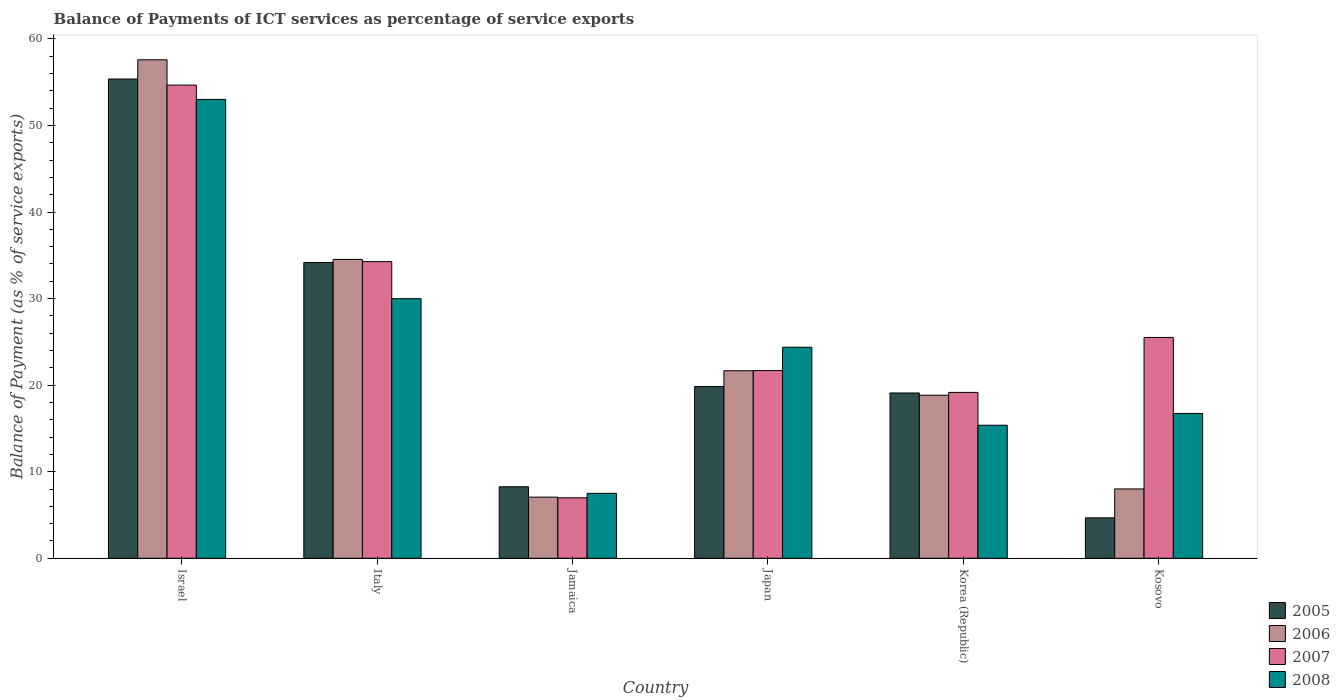How many different coloured bars are there?
Keep it short and to the point. 4. How many groups of bars are there?
Your answer should be compact. 6. What is the label of the 1st group of bars from the left?
Offer a terse response. Israel. In how many cases, is the number of bars for a given country not equal to the number of legend labels?
Ensure brevity in your answer.  0. What is the balance of payments of ICT services in 2006 in Jamaica?
Your answer should be compact. 7.06. Across all countries, what is the maximum balance of payments of ICT services in 2005?
Your response must be concise. 55.37. Across all countries, what is the minimum balance of payments of ICT services in 2006?
Your response must be concise. 7.06. In which country was the balance of payments of ICT services in 2008 maximum?
Give a very brief answer. Israel. In which country was the balance of payments of ICT services in 2005 minimum?
Provide a short and direct response. Kosovo. What is the total balance of payments of ICT services in 2006 in the graph?
Your response must be concise. 147.7. What is the difference between the balance of payments of ICT services in 2006 in Israel and that in Korea (Republic)?
Provide a short and direct response. 38.75. What is the difference between the balance of payments of ICT services in 2005 in Japan and the balance of payments of ICT services in 2006 in Italy?
Your response must be concise. -14.68. What is the average balance of payments of ICT services in 2008 per country?
Offer a terse response. 24.5. What is the difference between the balance of payments of ICT services of/in 2007 and balance of payments of ICT services of/in 2005 in Kosovo?
Keep it short and to the point. 20.84. What is the ratio of the balance of payments of ICT services in 2008 in Jamaica to that in Korea (Republic)?
Provide a succinct answer. 0.49. What is the difference between the highest and the second highest balance of payments of ICT services in 2008?
Give a very brief answer. -5.61. What is the difference between the highest and the lowest balance of payments of ICT services in 2006?
Give a very brief answer. 50.53. Is the sum of the balance of payments of ICT services in 2006 in Japan and Korea (Republic) greater than the maximum balance of payments of ICT services in 2007 across all countries?
Give a very brief answer. No. What does the 2nd bar from the left in Kosovo represents?
Offer a terse response. 2006. Is it the case that in every country, the sum of the balance of payments of ICT services in 2007 and balance of payments of ICT services in 2006 is greater than the balance of payments of ICT services in 2005?
Keep it short and to the point. Yes. Are all the bars in the graph horizontal?
Provide a succinct answer. No. Are the values on the major ticks of Y-axis written in scientific E-notation?
Ensure brevity in your answer.  No. Does the graph contain grids?
Keep it short and to the point. No. Where does the legend appear in the graph?
Your answer should be very brief. Bottom right. How many legend labels are there?
Offer a terse response. 4. What is the title of the graph?
Your answer should be compact. Balance of Payments of ICT services as percentage of service exports. Does "1991" appear as one of the legend labels in the graph?
Give a very brief answer. No. What is the label or title of the Y-axis?
Your answer should be compact. Balance of Payment (as % of service exports). What is the Balance of Payment (as % of service exports) in 2005 in Israel?
Provide a succinct answer. 55.37. What is the Balance of Payment (as % of service exports) in 2006 in Israel?
Offer a terse response. 57.59. What is the Balance of Payment (as % of service exports) in 2007 in Israel?
Your response must be concise. 54.67. What is the Balance of Payment (as % of service exports) in 2008 in Israel?
Offer a terse response. 53.02. What is the Balance of Payment (as % of service exports) in 2005 in Italy?
Your answer should be very brief. 34.17. What is the Balance of Payment (as % of service exports) of 2006 in Italy?
Offer a very short reply. 34.53. What is the Balance of Payment (as % of service exports) in 2007 in Italy?
Ensure brevity in your answer.  34.28. What is the Balance of Payment (as % of service exports) of 2008 in Italy?
Provide a short and direct response. 29.99. What is the Balance of Payment (as % of service exports) of 2005 in Jamaica?
Offer a very short reply. 8.26. What is the Balance of Payment (as % of service exports) in 2006 in Jamaica?
Your answer should be compact. 7.06. What is the Balance of Payment (as % of service exports) in 2007 in Jamaica?
Provide a succinct answer. 6.99. What is the Balance of Payment (as % of service exports) in 2008 in Jamaica?
Provide a short and direct response. 7.5. What is the Balance of Payment (as % of service exports) in 2005 in Japan?
Offer a very short reply. 19.85. What is the Balance of Payment (as % of service exports) of 2006 in Japan?
Your answer should be compact. 21.67. What is the Balance of Payment (as % of service exports) of 2007 in Japan?
Provide a short and direct response. 21.69. What is the Balance of Payment (as % of service exports) in 2008 in Japan?
Keep it short and to the point. 24.38. What is the Balance of Payment (as % of service exports) of 2005 in Korea (Republic)?
Make the answer very short. 19.1. What is the Balance of Payment (as % of service exports) of 2006 in Korea (Republic)?
Your answer should be compact. 18.84. What is the Balance of Payment (as % of service exports) in 2007 in Korea (Republic)?
Give a very brief answer. 19.16. What is the Balance of Payment (as % of service exports) in 2008 in Korea (Republic)?
Make the answer very short. 15.37. What is the Balance of Payment (as % of service exports) of 2005 in Kosovo?
Ensure brevity in your answer.  4.67. What is the Balance of Payment (as % of service exports) of 2006 in Kosovo?
Ensure brevity in your answer.  8.01. What is the Balance of Payment (as % of service exports) of 2007 in Kosovo?
Your response must be concise. 25.51. What is the Balance of Payment (as % of service exports) of 2008 in Kosovo?
Keep it short and to the point. 16.73. Across all countries, what is the maximum Balance of Payment (as % of service exports) of 2005?
Make the answer very short. 55.37. Across all countries, what is the maximum Balance of Payment (as % of service exports) of 2006?
Your response must be concise. 57.59. Across all countries, what is the maximum Balance of Payment (as % of service exports) in 2007?
Make the answer very short. 54.67. Across all countries, what is the maximum Balance of Payment (as % of service exports) of 2008?
Offer a very short reply. 53.02. Across all countries, what is the minimum Balance of Payment (as % of service exports) in 2005?
Provide a short and direct response. 4.67. Across all countries, what is the minimum Balance of Payment (as % of service exports) in 2006?
Your answer should be compact. 7.06. Across all countries, what is the minimum Balance of Payment (as % of service exports) of 2007?
Ensure brevity in your answer.  6.99. Across all countries, what is the minimum Balance of Payment (as % of service exports) in 2008?
Your response must be concise. 7.5. What is the total Balance of Payment (as % of service exports) in 2005 in the graph?
Keep it short and to the point. 141.43. What is the total Balance of Payment (as % of service exports) of 2006 in the graph?
Make the answer very short. 147.7. What is the total Balance of Payment (as % of service exports) of 2007 in the graph?
Provide a short and direct response. 162.29. What is the total Balance of Payment (as % of service exports) in 2008 in the graph?
Your answer should be compact. 147. What is the difference between the Balance of Payment (as % of service exports) of 2005 in Israel and that in Italy?
Provide a succinct answer. 21.2. What is the difference between the Balance of Payment (as % of service exports) of 2006 in Israel and that in Italy?
Make the answer very short. 23.06. What is the difference between the Balance of Payment (as % of service exports) of 2007 in Israel and that in Italy?
Your response must be concise. 20.39. What is the difference between the Balance of Payment (as % of service exports) in 2008 in Israel and that in Italy?
Your answer should be compact. 23.02. What is the difference between the Balance of Payment (as % of service exports) in 2005 in Israel and that in Jamaica?
Ensure brevity in your answer.  47.11. What is the difference between the Balance of Payment (as % of service exports) of 2006 in Israel and that in Jamaica?
Your response must be concise. 50.53. What is the difference between the Balance of Payment (as % of service exports) of 2007 in Israel and that in Jamaica?
Make the answer very short. 47.68. What is the difference between the Balance of Payment (as % of service exports) of 2008 in Israel and that in Jamaica?
Your answer should be very brief. 45.51. What is the difference between the Balance of Payment (as % of service exports) in 2005 in Israel and that in Japan?
Offer a terse response. 35.52. What is the difference between the Balance of Payment (as % of service exports) of 2006 in Israel and that in Japan?
Offer a very short reply. 35.93. What is the difference between the Balance of Payment (as % of service exports) of 2007 in Israel and that in Japan?
Offer a very short reply. 32.98. What is the difference between the Balance of Payment (as % of service exports) of 2008 in Israel and that in Japan?
Ensure brevity in your answer.  28.64. What is the difference between the Balance of Payment (as % of service exports) of 2005 in Israel and that in Korea (Republic)?
Provide a succinct answer. 36.28. What is the difference between the Balance of Payment (as % of service exports) of 2006 in Israel and that in Korea (Republic)?
Give a very brief answer. 38.75. What is the difference between the Balance of Payment (as % of service exports) of 2007 in Israel and that in Korea (Republic)?
Give a very brief answer. 35.5. What is the difference between the Balance of Payment (as % of service exports) of 2008 in Israel and that in Korea (Republic)?
Your answer should be compact. 37.64. What is the difference between the Balance of Payment (as % of service exports) in 2005 in Israel and that in Kosovo?
Your response must be concise. 50.7. What is the difference between the Balance of Payment (as % of service exports) of 2006 in Israel and that in Kosovo?
Ensure brevity in your answer.  49.58. What is the difference between the Balance of Payment (as % of service exports) of 2007 in Israel and that in Kosovo?
Provide a succinct answer. 29.15. What is the difference between the Balance of Payment (as % of service exports) of 2008 in Israel and that in Kosovo?
Your answer should be very brief. 36.29. What is the difference between the Balance of Payment (as % of service exports) of 2005 in Italy and that in Jamaica?
Ensure brevity in your answer.  25.91. What is the difference between the Balance of Payment (as % of service exports) in 2006 in Italy and that in Jamaica?
Your answer should be very brief. 27.47. What is the difference between the Balance of Payment (as % of service exports) in 2007 in Italy and that in Jamaica?
Give a very brief answer. 27.29. What is the difference between the Balance of Payment (as % of service exports) in 2008 in Italy and that in Jamaica?
Provide a short and direct response. 22.49. What is the difference between the Balance of Payment (as % of service exports) of 2005 in Italy and that in Japan?
Ensure brevity in your answer.  14.33. What is the difference between the Balance of Payment (as % of service exports) in 2006 in Italy and that in Japan?
Make the answer very short. 12.87. What is the difference between the Balance of Payment (as % of service exports) in 2007 in Italy and that in Japan?
Ensure brevity in your answer.  12.59. What is the difference between the Balance of Payment (as % of service exports) in 2008 in Italy and that in Japan?
Offer a very short reply. 5.61. What is the difference between the Balance of Payment (as % of service exports) in 2005 in Italy and that in Korea (Republic)?
Offer a very short reply. 15.08. What is the difference between the Balance of Payment (as % of service exports) of 2006 in Italy and that in Korea (Republic)?
Ensure brevity in your answer.  15.69. What is the difference between the Balance of Payment (as % of service exports) in 2007 in Italy and that in Korea (Republic)?
Your response must be concise. 15.11. What is the difference between the Balance of Payment (as % of service exports) in 2008 in Italy and that in Korea (Republic)?
Make the answer very short. 14.62. What is the difference between the Balance of Payment (as % of service exports) in 2005 in Italy and that in Kosovo?
Offer a very short reply. 29.5. What is the difference between the Balance of Payment (as % of service exports) of 2006 in Italy and that in Kosovo?
Offer a terse response. 26.52. What is the difference between the Balance of Payment (as % of service exports) of 2007 in Italy and that in Kosovo?
Make the answer very short. 8.76. What is the difference between the Balance of Payment (as % of service exports) of 2008 in Italy and that in Kosovo?
Offer a terse response. 13.26. What is the difference between the Balance of Payment (as % of service exports) in 2005 in Jamaica and that in Japan?
Provide a succinct answer. -11.59. What is the difference between the Balance of Payment (as % of service exports) of 2006 in Jamaica and that in Japan?
Your answer should be compact. -14.6. What is the difference between the Balance of Payment (as % of service exports) of 2007 in Jamaica and that in Japan?
Offer a very short reply. -14.7. What is the difference between the Balance of Payment (as % of service exports) of 2008 in Jamaica and that in Japan?
Provide a short and direct response. -16.88. What is the difference between the Balance of Payment (as % of service exports) in 2005 in Jamaica and that in Korea (Republic)?
Ensure brevity in your answer.  -10.83. What is the difference between the Balance of Payment (as % of service exports) of 2006 in Jamaica and that in Korea (Republic)?
Provide a short and direct response. -11.78. What is the difference between the Balance of Payment (as % of service exports) in 2007 in Jamaica and that in Korea (Republic)?
Provide a succinct answer. -12.18. What is the difference between the Balance of Payment (as % of service exports) of 2008 in Jamaica and that in Korea (Republic)?
Make the answer very short. -7.87. What is the difference between the Balance of Payment (as % of service exports) in 2005 in Jamaica and that in Kosovo?
Ensure brevity in your answer.  3.59. What is the difference between the Balance of Payment (as % of service exports) of 2006 in Jamaica and that in Kosovo?
Make the answer very short. -0.95. What is the difference between the Balance of Payment (as % of service exports) in 2007 in Jamaica and that in Kosovo?
Keep it short and to the point. -18.53. What is the difference between the Balance of Payment (as % of service exports) of 2008 in Jamaica and that in Kosovo?
Ensure brevity in your answer.  -9.23. What is the difference between the Balance of Payment (as % of service exports) in 2005 in Japan and that in Korea (Republic)?
Ensure brevity in your answer.  0.75. What is the difference between the Balance of Payment (as % of service exports) of 2006 in Japan and that in Korea (Republic)?
Offer a terse response. 2.83. What is the difference between the Balance of Payment (as % of service exports) in 2007 in Japan and that in Korea (Republic)?
Provide a short and direct response. 2.52. What is the difference between the Balance of Payment (as % of service exports) of 2008 in Japan and that in Korea (Republic)?
Offer a terse response. 9.01. What is the difference between the Balance of Payment (as % of service exports) in 2005 in Japan and that in Kosovo?
Keep it short and to the point. 15.18. What is the difference between the Balance of Payment (as % of service exports) of 2006 in Japan and that in Kosovo?
Give a very brief answer. 13.66. What is the difference between the Balance of Payment (as % of service exports) of 2007 in Japan and that in Kosovo?
Make the answer very short. -3.83. What is the difference between the Balance of Payment (as % of service exports) of 2008 in Japan and that in Kosovo?
Provide a short and direct response. 7.65. What is the difference between the Balance of Payment (as % of service exports) in 2005 in Korea (Republic) and that in Kosovo?
Offer a very short reply. 14.43. What is the difference between the Balance of Payment (as % of service exports) in 2006 in Korea (Republic) and that in Kosovo?
Provide a short and direct response. 10.83. What is the difference between the Balance of Payment (as % of service exports) of 2007 in Korea (Republic) and that in Kosovo?
Give a very brief answer. -6.35. What is the difference between the Balance of Payment (as % of service exports) in 2008 in Korea (Republic) and that in Kosovo?
Offer a very short reply. -1.36. What is the difference between the Balance of Payment (as % of service exports) in 2005 in Israel and the Balance of Payment (as % of service exports) in 2006 in Italy?
Provide a short and direct response. 20.84. What is the difference between the Balance of Payment (as % of service exports) of 2005 in Israel and the Balance of Payment (as % of service exports) of 2007 in Italy?
Provide a succinct answer. 21.1. What is the difference between the Balance of Payment (as % of service exports) of 2005 in Israel and the Balance of Payment (as % of service exports) of 2008 in Italy?
Provide a short and direct response. 25.38. What is the difference between the Balance of Payment (as % of service exports) of 2006 in Israel and the Balance of Payment (as % of service exports) of 2007 in Italy?
Your answer should be very brief. 23.32. What is the difference between the Balance of Payment (as % of service exports) in 2006 in Israel and the Balance of Payment (as % of service exports) in 2008 in Italy?
Give a very brief answer. 27.6. What is the difference between the Balance of Payment (as % of service exports) of 2007 in Israel and the Balance of Payment (as % of service exports) of 2008 in Italy?
Your answer should be very brief. 24.67. What is the difference between the Balance of Payment (as % of service exports) in 2005 in Israel and the Balance of Payment (as % of service exports) in 2006 in Jamaica?
Your response must be concise. 48.31. What is the difference between the Balance of Payment (as % of service exports) of 2005 in Israel and the Balance of Payment (as % of service exports) of 2007 in Jamaica?
Offer a very short reply. 48.39. What is the difference between the Balance of Payment (as % of service exports) of 2005 in Israel and the Balance of Payment (as % of service exports) of 2008 in Jamaica?
Your answer should be very brief. 47.87. What is the difference between the Balance of Payment (as % of service exports) in 2006 in Israel and the Balance of Payment (as % of service exports) in 2007 in Jamaica?
Offer a terse response. 50.61. What is the difference between the Balance of Payment (as % of service exports) in 2006 in Israel and the Balance of Payment (as % of service exports) in 2008 in Jamaica?
Ensure brevity in your answer.  50.09. What is the difference between the Balance of Payment (as % of service exports) of 2007 in Israel and the Balance of Payment (as % of service exports) of 2008 in Jamaica?
Make the answer very short. 47.16. What is the difference between the Balance of Payment (as % of service exports) in 2005 in Israel and the Balance of Payment (as % of service exports) in 2006 in Japan?
Give a very brief answer. 33.71. What is the difference between the Balance of Payment (as % of service exports) in 2005 in Israel and the Balance of Payment (as % of service exports) in 2007 in Japan?
Offer a very short reply. 33.69. What is the difference between the Balance of Payment (as % of service exports) in 2005 in Israel and the Balance of Payment (as % of service exports) in 2008 in Japan?
Give a very brief answer. 30.99. What is the difference between the Balance of Payment (as % of service exports) of 2006 in Israel and the Balance of Payment (as % of service exports) of 2007 in Japan?
Your answer should be compact. 35.91. What is the difference between the Balance of Payment (as % of service exports) in 2006 in Israel and the Balance of Payment (as % of service exports) in 2008 in Japan?
Give a very brief answer. 33.21. What is the difference between the Balance of Payment (as % of service exports) in 2007 in Israel and the Balance of Payment (as % of service exports) in 2008 in Japan?
Make the answer very short. 30.28. What is the difference between the Balance of Payment (as % of service exports) in 2005 in Israel and the Balance of Payment (as % of service exports) in 2006 in Korea (Republic)?
Your answer should be compact. 36.53. What is the difference between the Balance of Payment (as % of service exports) in 2005 in Israel and the Balance of Payment (as % of service exports) in 2007 in Korea (Republic)?
Your answer should be very brief. 36.21. What is the difference between the Balance of Payment (as % of service exports) in 2005 in Israel and the Balance of Payment (as % of service exports) in 2008 in Korea (Republic)?
Ensure brevity in your answer.  40. What is the difference between the Balance of Payment (as % of service exports) in 2006 in Israel and the Balance of Payment (as % of service exports) in 2007 in Korea (Republic)?
Provide a succinct answer. 38.43. What is the difference between the Balance of Payment (as % of service exports) of 2006 in Israel and the Balance of Payment (as % of service exports) of 2008 in Korea (Republic)?
Your answer should be compact. 42.22. What is the difference between the Balance of Payment (as % of service exports) of 2007 in Israel and the Balance of Payment (as % of service exports) of 2008 in Korea (Republic)?
Provide a short and direct response. 39.29. What is the difference between the Balance of Payment (as % of service exports) of 2005 in Israel and the Balance of Payment (as % of service exports) of 2006 in Kosovo?
Offer a terse response. 47.36. What is the difference between the Balance of Payment (as % of service exports) of 2005 in Israel and the Balance of Payment (as % of service exports) of 2007 in Kosovo?
Your response must be concise. 29.86. What is the difference between the Balance of Payment (as % of service exports) of 2005 in Israel and the Balance of Payment (as % of service exports) of 2008 in Kosovo?
Give a very brief answer. 38.64. What is the difference between the Balance of Payment (as % of service exports) in 2006 in Israel and the Balance of Payment (as % of service exports) in 2007 in Kosovo?
Your response must be concise. 32.08. What is the difference between the Balance of Payment (as % of service exports) in 2006 in Israel and the Balance of Payment (as % of service exports) in 2008 in Kosovo?
Provide a short and direct response. 40.86. What is the difference between the Balance of Payment (as % of service exports) of 2007 in Israel and the Balance of Payment (as % of service exports) of 2008 in Kosovo?
Provide a succinct answer. 37.94. What is the difference between the Balance of Payment (as % of service exports) of 2005 in Italy and the Balance of Payment (as % of service exports) of 2006 in Jamaica?
Keep it short and to the point. 27.11. What is the difference between the Balance of Payment (as % of service exports) of 2005 in Italy and the Balance of Payment (as % of service exports) of 2007 in Jamaica?
Provide a succinct answer. 27.19. What is the difference between the Balance of Payment (as % of service exports) of 2005 in Italy and the Balance of Payment (as % of service exports) of 2008 in Jamaica?
Ensure brevity in your answer.  26.67. What is the difference between the Balance of Payment (as % of service exports) in 2006 in Italy and the Balance of Payment (as % of service exports) in 2007 in Jamaica?
Provide a short and direct response. 27.54. What is the difference between the Balance of Payment (as % of service exports) in 2006 in Italy and the Balance of Payment (as % of service exports) in 2008 in Jamaica?
Offer a very short reply. 27.03. What is the difference between the Balance of Payment (as % of service exports) of 2007 in Italy and the Balance of Payment (as % of service exports) of 2008 in Jamaica?
Your response must be concise. 26.77. What is the difference between the Balance of Payment (as % of service exports) of 2005 in Italy and the Balance of Payment (as % of service exports) of 2006 in Japan?
Your response must be concise. 12.51. What is the difference between the Balance of Payment (as % of service exports) of 2005 in Italy and the Balance of Payment (as % of service exports) of 2007 in Japan?
Offer a terse response. 12.49. What is the difference between the Balance of Payment (as % of service exports) in 2005 in Italy and the Balance of Payment (as % of service exports) in 2008 in Japan?
Keep it short and to the point. 9.79. What is the difference between the Balance of Payment (as % of service exports) of 2006 in Italy and the Balance of Payment (as % of service exports) of 2007 in Japan?
Provide a succinct answer. 12.85. What is the difference between the Balance of Payment (as % of service exports) in 2006 in Italy and the Balance of Payment (as % of service exports) in 2008 in Japan?
Keep it short and to the point. 10.15. What is the difference between the Balance of Payment (as % of service exports) in 2007 in Italy and the Balance of Payment (as % of service exports) in 2008 in Japan?
Make the answer very short. 9.89. What is the difference between the Balance of Payment (as % of service exports) in 2005 in Italy and the Balance of Payment (as % of service exports) in 2006 in Korea (Republic)?
Your answer should be compact. 15.34. What is the difference between the Balance of Payment (as % of service exports) in 2005 in Italy and the Balance of Payment (as % of service exports) in 2007 in Korea (Republic)?
Your answer should be very brief. 15.01. What is the difference between the Balance of Payment (as % of service exports) of 2005 in Italy and the Balance of Payment (as % of service exports) of 2008 in Korea (Republic)?
Offer a very short reply. 18.8. What is the difference between the Balance of Payment (as % of service exports) in 2006 in Italy and the Balance of Payment (as % of service exports) in 2007 in Korea (Republic)?
Your answer should be compact. 15.37. What is the difference between the Balance of Payment (as % of service exports) of 2006 in Italy and the Balance of Payment (as % of service exports) of 2008 in Korea (Republic)?
Keep it short and to the point. 19.16. What is the difference between the Balance of Payment (as % of service exports) of 2007 in Italy and the Balance of Payment (as % of service exports) of 2008 in Korea (Republic)?
Ensure brevity in your answer.  18.9. What is the difference between the Balance of Payment (as % of service exports) of 2005 in Italy and the Balance of Payment (as % of service exports) of 2006 in Kosovo?
Provide a succinct answer. 26.16. What is the difference between the Balance of Payment (as % of service exports) in 2005 in Italy and the Balance of Payment (as % of service exports) in 2007 in Kosovo?
Ensure brevity in your answer.  8.66. What is the difference between the Balance of Payment (as % of service exports) of 2005 in Italy and the Balance of Payment (as % of service exports) of 2008 in Kosovo?
Your answer should be compact. 17.44. What is the difference between the Balance of Payment (as % of service exports) in 2006 in Italy and the Balance of Payment (as % of service exports) in 2007 in Kosovo?
Provide a succinct answer. 9.02. What is the difference between the Balance of Payment (as % of service exports) in 2006 in Italy and the Balance of Payment (as % of service exports) in 2008 in Kosovo?
Your answer should be very brief. 17.8. What is the difference between the Balance of Payment (as % of service exports) of 2007 in Italy and the Balance of Payment (as % of service exports) of 2008 in Kosovo?
Make the answer very short. 17.54. What is the difference between the Balance of Payment (as % of service exports) of 2005 in Jamaica and the Balance of Payment (as % of service exports) of 2006 in Japan?
Keep it short and to the point. -13.4. What is the difference between the Balance of Payment (as % of service exports) in 2005 in Jamaica and the Balance of Payment (as % of service exports) in 2007 in Japan?
Your answer should be compact. -13.42. What is the difference between the Balance of Payment (as % of service exports) of 2005 in Jamaica and the Balance of Payment (as % of service exports) of 2008 in Japan?
Give a very brief answer. -16.12. What is the difference between the Balance of Payment (as % of service exports) in 2006 in Jamaica and the Balance of Payment (as % of service exports) in 2007 in Japan?
Provide a short and direct response. -14.62. What is the difference between the Balance of Payment (as % of service exports) of 2006 in Jamaica and the Balance of Payment (as % of service exports) of 2008 in Japan?
Give a very brief answer. -17.32. What is the difference between the Balance of Payment (as % of service exports) of 2007 in Jamaica and the Balance of Payment (as % of service exports) of 2008 in Japan?
Offer a terse response. -17.39. What is the difference between the Balance of Payment (as % of service exports) of 2005 in Jamaica and the Balance of Payment (as % of service exports) of 2006 in Korea (Republic)?
Your answer should be compact. -10.58. What is the difference between the Balance of Payment (as % of service exports) in 2005 in Jamaica and the Balance of Payment (as % of service exports) in 2007 in Korea (Republic)?
Provide a succinct answer. -10.9. What is the difference between the Balance of Payment (as % of service exports) in 2005 in Jamaica and the Balance of Payment (as % of service exports) in 2008 in Korea (Republic)?
Offer a terse response. -7.11. What is the difference between the Balance of Payment (as % of service exports) in 2006 in Jamaica and the Balance of Payment (as % of service exports) in 2007 in Korea (Republic)?
Give a very brief answer. -12.1. What is the difference between the Balance of Payment (as % of service exports) in 2006 in Jamaica and the Balance of Payment (as % of service exports) in 2008 in Korea (Republic)?
Ensure brevity in your answer.  -8.31. What is the difference between the Balance of Payment (as % of service exports) of 2007 in Jamaica and the Balance of Payment (as % of service exports) of 2008 in Korea (Republic)?
Ensure brevity in your answer.  -8.39. What is the difference between the Balance of Payment (as % of service exports) of 2005 in Jamaica and the Balance of Payment (as % of service exports) of 2006 in Kosovo?
Offer a very short reply. 0.25. What is the difference between the Balance of Payment (as % of service exports) in 2005 in Jamaica and the Balance of Payment (as % of service exports) in 2007 in Kosovo?
Make the answer very short. -17.25. What is the difference between the Balance of Payment (as % of service exports) of 2005 in Jamaica and the Balance of Payment (as % of service exports) of 2008 in Kosovo?
Your answer should be compact. -8.47. What is the difference between the Balance of Payment (as % of service exports) in 2006 in Jamaica and the Balance of Payment (as % of service exports) in 2007 in Kosovo?
Your answer should be very brief. -18.45. What is the difference between the Balance of Payment (as % of service exports) in 2006 in Jamaica and the Balance of Payment (as % of service exports) in 2008 in Kosovo?
Give a very brief answer. -9.67. What is the difference between the Balance of Payment (as % of service exports) in 2007 in Jamaica and the Balance of Payment (as % of service exports) in 2008 in Kosovo?
Provide a succinct answer. -9.74. What is the difference between the Balance of Payment (as % of service exports) in 2005 in Japan and the Balance of Payment (as % of service exports) in 2006 in Korea (Republic)?
Keep it short and to the point. 1.01. What is the difference between the Balance of Payment (as % of service exports) in 2005 in Japan and the Balance of Payment (as % of service exports) in 2007 in Korea (Republic)?
Your response must be concise. 0.68. What is the difference between the Balance of Payment (as % of service exports) of 2005 in Japan and the Balance of Payment (as % of service exports) of 2008 in Korea (Republic)?
Your response must be concise. 4.48. What is the difference between the Balance of Payment (as % of service exports) of 2006 in Japan and the Balance of Payment (as % of service exports) of 2007 in Korea (Republic)?
Keep it short and to the point. 2.5. What is the difference between the Balance of Payment (as % of service exports) in 2006 in Japan and the Balance of Payment (as % of service exports) in 2008 in Korea (Republic)?
Make the answer very short. 6.29. What is the difference between the Balance of Payment (as % of service exports) of 2007 in Japan and the Balance of Payment (as % of service exports) of 2008 in Korea (Republic)?
Provide a short and direct response. 6.31. What is the difference between the Balance of Payment (as % of service exports) in 2005 in Japan and the Balance of Payment (as % of service exports) in 2006 in Kosovo?
Your response must be concise. 11.84. What is the difference between the Balance of Payment (as % of service exports) in 2005 in Japan and the Balance of Payment (as % of service exports) in 2007 in Kosovo?
Offer a very short reply. -5.67. What is the difference between the Balance of Payment (as % of service exports) of 2005 in Japan and the Balance of Payment (as % of service exports) of 2008 in Kosovo?
Keep it short and to the point. 3.12. What is the difference between the Balance of Payment (as % of service exports) in 2006 in Japan and the Balance of Payment (as % of service exports) in 2007 in Kosovo?
Provide a succinct answer. -3.85. What is the difference between the Balance of Payment (as % of service exports) of 2006 in Japan and the Balance of Payment (as % of service exports) of 2008 in Kosovo?
Ensure brevity in your answer.  4.93. What is the difference between the Balance of Payment (as % of service exports) in 2007 in Japan and the Balance of Payment (as % of service exports) in 2008 in Kosovo?
Your answer should be compact. 4.95. What is the difference between the Balance of Payment (as % of service exports) of 2005 in Korea (Republic) and the Balance of Payment (as % of service exports) of 2006 in Kosovo?
Offer a terse response. 11.09. What is the difference between the Balance of Payment (as % of service exports) of 2005 in Korea (Republic) and the Balance of Payment (as % of service exports) of 2007 in Kosovo?
Ensure brevity in your answer.  -6.42. What is the difference between the Balance of Payment (as % of service exports) of 2005 in Korea (Republic) and the Balance of Payment (as % of service exports) of 2008 in Kosovo?
Your response must be concise. 2.37. What is the difference between the Balance of Payment (as % of service exports) of 2006 in Korea (Republic) and the Balance of Payment (as % of service exports) of 2007 in Kosovo?
Make the answer very short. -6.68. What is the difference between the Balance of Payment (as % of service exports) of 2006 in Korea (Republic) and the Balance of Payment (as % of service exports) of 2008 in Kosovo?
Keep it short and to the point. 2.11. What is the difference between the Balance of Payment (as % of service exports) of 2007 in Korea (Republic) and the Balance of Payment (as % of service exports) of 2008 in Kosovo?
Your answer should be compact. 2.43. What is the average Balance of Payment (as % of service exports) of 2005 per country?
Offer a terse response. 23.57. What is the average Balance of Payment (as % of service exports) of 2006 per country?
Ensure brevity in your answer.  24.62. What is the average Balance of Payment (as % of service exports) in 2007 per country?
Your answer should be very brief. 27.05. What is the average Balance of Payment (as % of service exports) of 2008 per country?
Offer a very short reply. 24.5. What is the difference between the Balance of Payment (as % of service exports) of 2005 and Balance of Payment (as % of service exports) of 2006 in Israel?
Offer a very short reply. -2.22. What is the difference between the Balance of Payment (as % of service exports) in 2005 and Balance of Payment (as % of service exports) in 2007 in Israel?
Your answer should be very brief. 0.71. What is the difference between the Balance of Payment (as % of service exports) in 2005 and Balance of Payment (as % of service exports) in 2008 in Israel?
Make the answer very short. 2.36. What is the difference between the Balance of Payment (as % of service exports) of 2006 and Balance of Payment (as % of service exports) of 2007 in Israel?
Offer a very short reply. 2.93. What is the difference between the Balance of Payment (as % of service exports) of 2006 and Balance of Payment (as % of service exports) of 2008 in Israel?
Your response must be concise. 4.57. What is the difference between the Balance of Payment (as % of service exports) in 2007 and Balance of Payment (as % of service exports) in 2008 in Israel?
Provide a succinct answer. 1.65. What is the difference between the Balance of Payment (as % of service exports) of 2005 and Balance of Payment (as % of service exports) of 2006 in Italy?
Your answer should be compact. -0.36. What is the difference between the Balance of Payment (as % of service exports) of 2005 and Balance of Payment (as % of service exports) of 2007 in Italy?
Offer a very short reply. -0.1. What is the difference between the Balance of Payment (as % of service exports) of 2005 and Balance of Payment (as % of service exports) of 2008 in Italy?
Keep it short and to the point. 4.18. What is the difference between the Balance of Payment (as % of service exports) of 2006 and Balance of Payment (as % of service exports) of 2007 in Italy?
Keep it short and to the point. 0.26. What is the difference between the Balance of Payment (as % of service exports) of 2006 and Balance of Payment (as % of service exports) of 2008 in Italy?
Your answer should be compact. 4.54. What is the difference between the Balance of Payment (as % of service exports) in 2007 and Balance of Payment (as % of service exports) in 2008 in Italy?
Your answer should be very brief. 4.28. What is the difference between the Balance of Payment (as % of service exports) in 2005 and Balance of Payment (as % of service exports) in 2006 in Jamaica?
Offer a very short reply. 1.2. What is the difference between the Balance of Payment (as % of service exports) of 2005 and Balance of Payment (as % of service exports) of 2007 in Jamaica?
Provide a short and direct response. 1.28. What is the difference between the Balance of Payment (as % of service exports) of 2005 and Balance of Payment (as % of service exports) of 2008 in Jamaica?
Your response must be concise. 0.76. What is the difference between the Balance of Payment (as % of service exports) of 2006 and Balance of Payment (as % of service exports) of 2007 in Jamaica?
Make the answer very short. 0.08. What is the difference between the Balance of Payment (as % of service exports) in 2006 and Balance of Payment (as % of service exports) in 2008 in Jamaica?
Keep it short and to the point. -0.44. What is the difference between the Balance of Payment (as % of service exports) of 2007 and Balance of Payment (as % of service exports) of 2008 in Jamaica?
Provide a succinct answer. -0.52. What is the difference between the Balance of Payment (as % of service exports) in 2005 and Balance of Payment (as % of service exports) in 2006 in Japan?
Your response must be concise. -1.82. What is the difference between the Balance of Payment (as % of service exports) in 2005 and Balance of Payment (as % of service exports) in 2007 in Japan?
Provide a succinct answer. -1.84. What is the difference between the Balance of Payment (as % of service exports) in 2005 and Balance of Payment (as % of service exports) in 2008 in Japan?
Offer a terse response. -4.53. What is the difference between the Balance of Payment (as % of service exports) in 2006 and Balance of Payment (as % of service exports) in 2007 in Japan?
Keep it short and to the point. -0.02. What is the difference between the Balance of Payment (as % of service exports) in 2006 and Balance of Payment (as % of service exports) in 2008 in Japan?
Your answer should be very brief. -2.72. What is the difference between the Balance of Payment (as % of service exports) of 2007 and Balance of Payment (as % of service exports) of 2008 in Japan?
Your answer should be compact. -2.7. What is the difference between the Balance of Payment (as % of service exports) of 2005 and Balance of Payment (as % of service exports) of 2006 in Korea (Republic)?
Provide a short and direct response. 0.26. What is the difference between the Balance of Payment (as % of service exports) of 2005 and Balance of Payment (as % of service exports) of 2007 in Korea (Republic)?
Provide a short and direct response. -0.07. What is the difference between the Balance of Payment (as % of service exports) in 2005 and Balance of Payment (as % of service exports) in 2008 in Korea (Republic)?
Your answer should be very brief. 3.72. What is the difference between the Balance of Payment (as % of service exports) of 2006 and Balance of Payment (as % of service exports) of 2007 in Korea (Republic)?
Provide a short and direct response. -0.33. What is the difference between the Balance of Payment (as % of service exports) in 2006 and Balance of Payment (as % of service exports) in 2008 in Korea (Republic)?
Offer a terse response. 3.46. What is the difference between the Balance of Payment (as % of service exports) of 2007 and Balance of Payment (as % of service exports) of 2008 in Korea (Republic)?
Your response must be concise. 3.79. What is the difference between the Balance of Payment (as % of service exports) of 2005 and Balance of Payment (as % of service exports) of 2006 in Kosovo?
Your answer should be very brief. -3.34. What is the difference between the Balance of Payment (as % of service exports) in 2005 and Balance of Payment (as % of service exports) in 2007 in Kosovo?
Keep it short and to the point. -20.84. What is the difference between the Balance of Payment (as % of service exports) of 2005 and Balance of Payment (as % of service exports) of 2008 in Kosovo?
Your answer should be very brief. -12.06. What is the difference between the Balance of Payment (as % of service exports) in 2006 and Balance of Payment (as % of service exports) in 2007 in Kosovo?
Offer a terse response. -17.5. What is the difference between the Balance of Payment (as % of service exports) of 2006 and Balance of Payment (as % of service exports) of 2008 in Kosovo?
Make the answer very short. -8.72. What is the difference between the Balance of Payment (as % of service exports) in 2007 and Balance of Payment (as % of service exports) in 2008 in Kosovo?
Your answer should be very brief. 8.78. What is the ratio of the Balance of Payment (as % of service exports) in 2005 in Israel to that in Italy?
Your response must be concise. 1.62. What is the ratio of the Balance of Payment (as % of service exports) of 2006 in Israel to that in Italy?
Keep it short and to the point. 1.67. What is the ratio of the Balance of Payment (as % of service exports) of 2007 in Israel to that in Italy?
Give a very brief answer. 1.59. What is the ratio of the Balance of Payment (as % of service exports) of 2008 in Israel to that in Italy?
Your response must be concise. 1.77. What is the ratio of the Balance of Payment (as % of service exports) of 2005 in Israel to that in Jamaica?
Your answer should be compact. 6.7. What is the ratio of the Balance of Payment (as % of service exports) of 2006 in Israel to that in Jamaica?
Keep it short and to the point. 8.15. What is the ratio of the Balance of Payment (as % of service exports) in 2007 in Israel to that in Jamaica?
Make the answer very short. 7.82. What is the ratio of the Balance of Payment (as % of service exports) in 2008 in Israel to that in Jamaica?
Make the answer very short. 7.07. What is the ratio of the Balance of Payment (as % of service exports) in 2005 in Israel to that in Japan?
Provide a succinct answer. 2.79. What is the ratio of the Balance of Payment (as % of service exports) of 2006 in Israel to that in Japan?
Offer a terse response. 2.66. What is the ratio of the Balance of Payment (as % of service exports) in 2007 in Israel to that in Japan?
Your answer should be very brief. 2.52. What is the ratio of the Balance of Payment (as % of service exports) in 2008 in Israel to that in Japan?
Offer a terse response. 2.17. What is the ratio of the Balance of Payment (as % of service exports) in 2005 in Israel to that in Korea (Republic)?
Your answer should be compact. 2.9. What is the ratio of the Balance of Payment (as % of service exports) in 2006 in Israel to that in Korea (Republic)?
Your response must be concise. 3.06. What is the ratio of the Balance of Payment (as % of service exports) of 2007 in Israel to that in Korea (Republic)?
Provide a short and direct response. 2.85. What is the ratio of the Balance of Payment (as % of service exports) of 2008 in Israel to that in Korea (Republic)?
Provide a succinct answer. 3.45. What is the ratio of the Balance of Payment (as % of service exports) of 2005 in Israel to that in Kosovo?
Provide a short and direct response. 11.85. What is the ratio of the Balance of Payment (as % of service exports) of 2006 in Israel to that in Kosovo?
Offer a terse response. 7.19. What is the ratio of the Balance of Payment (as % of service exports) in 2007 in Israel to that in Kosovo?
Your response must be concise. 2.14. What is the ratio of the Balance of Payment (as % of service exports) in 2008 in Israel to that in Kosovo?
Offer a terse response. 3.17. What is the ratio of the Balance of Payment (as % of service exports) in 2005 in Italy to that in Jamaica?
Your answer should be very brief. 4.14. What is the ratio of the Balance of Payment (as % of service exports) in 2006 in Italy to that in Jamaica?
Your response must be concise. 4.89. What is the ratio of the Balance of Payment (as % of service exports) in 2007 in Italy to that in Jamaica?
Your response must be concise. 4.91. What is the ratio of the Balance of Payment (as % of service exports) of 2008 in Italy to that in Jamaica?
Provide a succinct answer. 4. What is the ratio of the Balance of Payment (as % of service exports) of 2005 in Italy to that in Japan?
Provide a succinct answer. 1.72. What is the ratio of the Balance of Payment (as % of service exports) of 2006 in Italy to that in Japan?
Provide a succinct answer. 1.59. What is the ratio of the Balance of Payment (as % of service exports) of 2007 in Italy to that in Japan?
Keep it short and to the point. 1.58. What is the ratio of the Balance of Payment (as % of service exports) of 2008 in Italy to that in Japan?
Ensure brevity in your answer.  1.23. What is the ratio of the Balance of Payment (as % of service exports) of 2005 in Italy to that in Korea (Republic)?
Provide a short and direct response. 1.79. What is the ratio of the Balance of Payment (as % of service exports) in 2006 in Italy to that in Korea (Republic)?
Your response must be concise. 1.83. What is the ratio of the Balance of Payment (as % of service exports) of 2007 in Italy to that in Korea (Republic)?
Make the answer very short. 1.79. What is the ratio of the Balance of Payment (as % of service exports) of 2008 in Italy to that in Korea (Republic)?
Offer a very short reply. 1.95. What is the ratio of the Balance of Payment (as % of service exports) in 2005 in Italy to that in Kosovo?
Offer a very short reply. 7.32. What is the ratio of the Balance of Payment (as % of service exports) in 2006 in Italy to that in Kosovo?
Provide a short and direct response. 4.31. What is the ratio of the Balance of Payment (as % of service exports) in 2007 in Italy to that in Kosovo?
Offer a terse response. 1.34. What is the ratio of the Balance of Payment (as % of service exports) in 2008 in Italy to that in Kosovo?
Keep it short and to the point. 1.79. What is the ratio of the Balance of Payment (as % of service exports) of 2005 in Jamaica to that in Japan?
Provide a succinct answer. 0.42. What is the ratio of the Balance of Payment (as % of service exports) in 2006 in Jamaica to that in Japan?
Your answer should be very brief. 0.33. What is the ratio of the Balance of Payment (as % of service exports) of 2007 in Jamaica to that in Japan?
Provide a succinct answer. 0.32. What is the ratio of the Balance of Payment (as % of service exports) of 2008 in Jamaica to that in Japan?
Your response must be concise. 0.31. What is the ratio of the Balance of Payment (as % of service exports) in 2005 in Jamaica to that in Korea (Republic)?
Provide a succinct answer. 0.43. What is the ratio of the Balance of Payment (as % of service exports) of 2006 in Jamaica to that in Korea (Republic)?
Your answer should be very brief. 0.37. What is the ratio of the Balance of Payment (as % of service exports) in 2007 in Jamaica to that in Korea (Republic)?
Provide a succinct answer. 0.36. What is the ratio of the Balance of Payment (as % of service exports) of 2008 in Jamaica to that in Korea (Republic)?
Offer a terse response. 0.49. What is the ratio of the Balance of Payment (as % of service exports) of 2005 in Jamaica to that in Kosovo?
Offer a terse response. 1.77. What is the ratio of the Balance of Payment (as % of service exports) in 2006 in Jamaica to that in Kosovo?
Give a very brief answer. 0.88. What is the ratio of the Balance of Payment (as % of service exports) in 2007 in Jamaica to that in Kosovo?
Make the answer very short. 0.27. What is the ratio of the Balance of Payment (as % of service exports) of 2008 in Jamaica to that in Kosovo?
Offer a very short reply. 0.45. What is the ratio of the Balance of Payment (as % of service exports) in 2005 in Japan to that in Korea (Republic)?
Your answer should be very brief. 1.04. What is the ratio of the Balance of Payment (as % of service exports) of 2006 in Japan to that in Korea (Republic)?
Offer a terse response. 1.15. What is the ratio of the Balance of Payment (as % of service exports) in 2007 in Japan to that in Korea (Republic)?
Make the answer very short. 1.13. What is the ratio of the Balance of Payment (as % of service exports) in 2008 in Japan to that in Korea (Republic)?
Your answer should be very brief. 1.59. What is the ratio of the Balance of Payment (as % of service exports) of 2005 in Japan to that in Kosovo?
Make the answer very short. 4.25. What is the ratio of the Balance of Payment (as % of service exports) in 2006 in Japan to that in Kosovo?
Your response must be concise. 2.7. What is the ratio of the Balance of Payment (as % of service exports) of 2007 in Japan to that in Kosovo?
Offer a terse response. 0.85. What is the ratio of the Balance of Payment (as % of service exports) of 2008 in Japan to that in Kosovo?
Make the answer very short. 1.46. What is the ratio of the Balance of Payment (as % of service exports) in 2005 in Korea (Republic) to that in Kosovo?
Keep it short and to the point. 4.09. What is the ratio of the Balance of Payment (as % of service exports) in 2006 in Korea (Republic) to that in Kosovo?
Provide a succinct answer. 2.35. What is the ratio of the Balance of Payment (as % of service exports) of 2007 in Korea (Republic) to that in Kosovo?
Provide a succinct answer. 0.75. What is the ratio of the Balance of Payment (as % of service exports) in 2008 in Korea (Republic) to that in Kosovo?
Ensure brevity in your answer.  0.92. What is the difference between the highest and the second highest Balance of Payment (as % of service exports) in 2005?
Keep it short and to the point. 21.2. What is the difference between the highest and the second highest Balance of Payment (as % of service exports) of 2006?
Your response must be concise. 23.06. What is the difference between the highest and the second highest Balance of Payment (as % of service exports) of 2007?
Your answer should be compact. 20.39. What is the difference between the highest and the second highest Balance of Payment (as % of service exports) in 2008?
Your answer should be compact. 23.02. What is the difference between the highest and the lowest Balance of Payment (as % of service exports) in 2005?
Provide a short and direct response. 50.7. What is the difference between the highest and the lowest Balance of Payment (as % of service exports) in 2006?
Provide a succinct answer. 50.53. What is the difference between the highest and the lowest Balance of Payment (as % of service exports) in 2007?
Give a very brief answer. 47.68. What is the difference between the highest and the lowest Balance of Payment (as % of service exports) in 2008?
Make the answer very short. 45.51. 